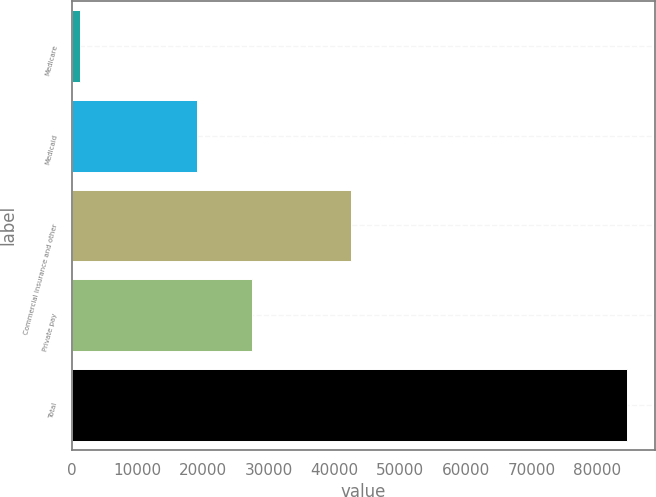Convert chart to OTSL. <chart><loc_0><loc_0><loc_500><loc_500><bar_chart><fcel>Medicare<fcel>Medicaid<fcel>Commercial insurance and other<fcel>Private pay<fcel>Total<nl><fcel>1214<fcel>19135<fcel>42459<fcel>27475.9<fcel>84623<nl></chart> 